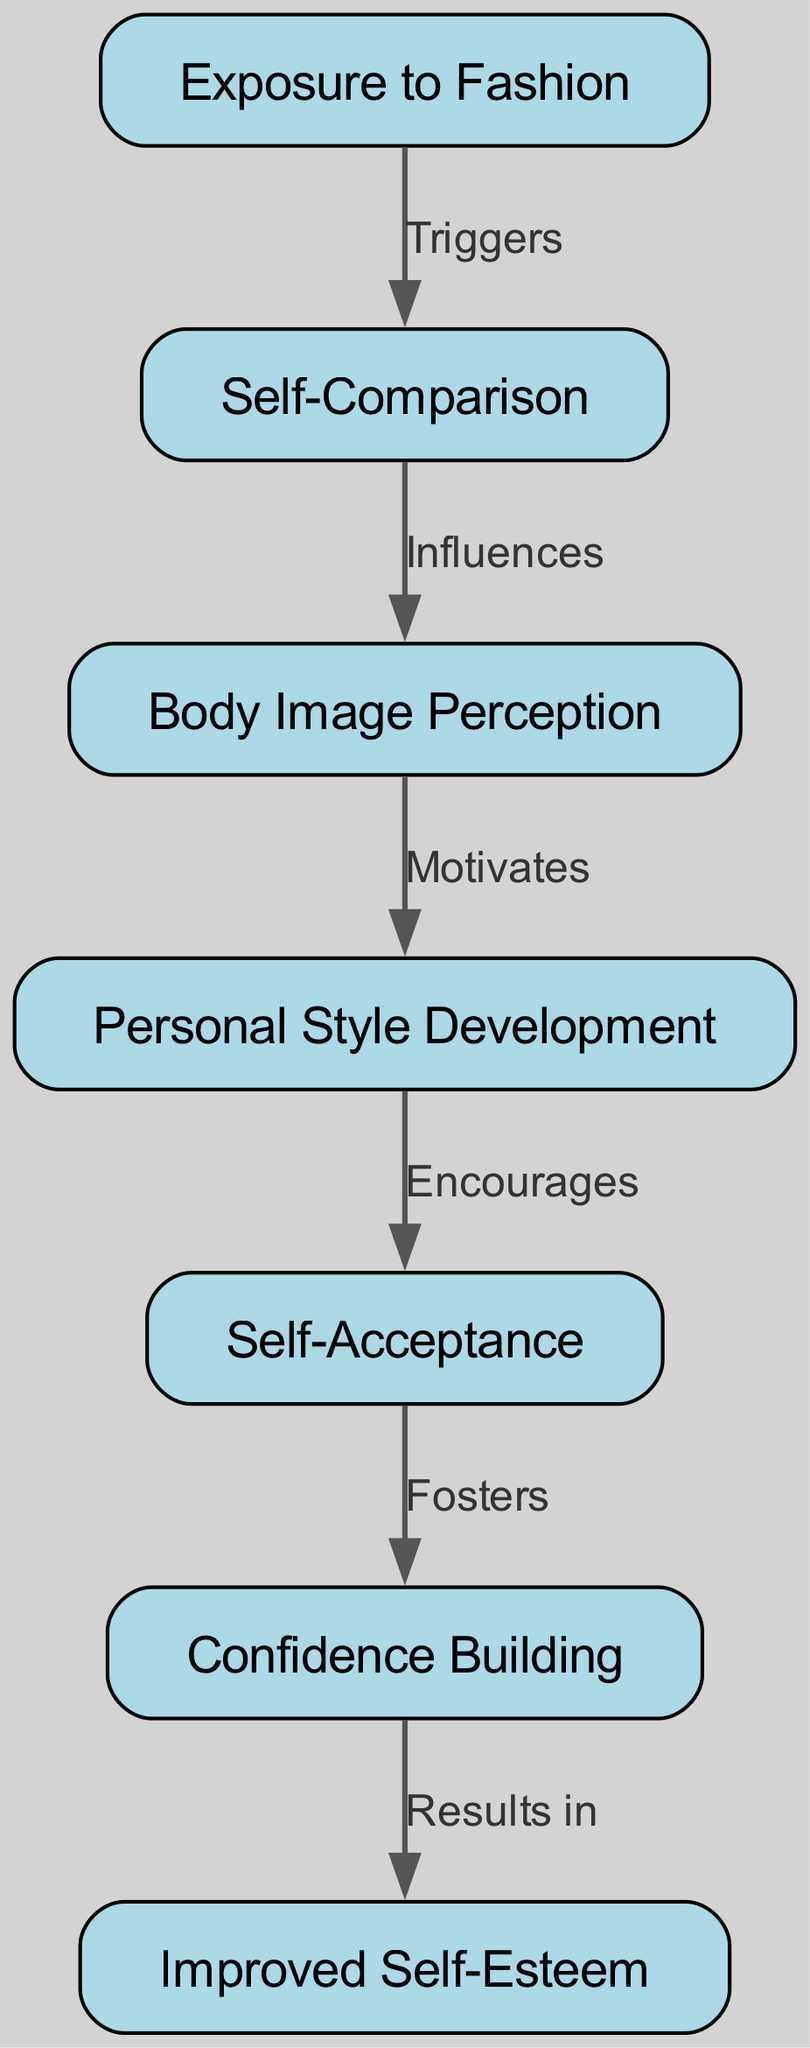What is the first node in the diagram? The first node is identified in the flowchart as the starting point of the cognitive processes illustrated. In this case, the first node is labeled "Exposure to Fashion."
Answer: Exposure to Fashion How many nodes are present in the diagram? To determine the number of nodes, we can count each individual node listed in the provided data under the "nodes" section. There are a total of 7 nodes in the diagram.
Answer: 7 What is the last node in the flowchart? The last node in the flowchart represents the final outcome of the cognitive processes described. It is labeled "Improved Self-Esteem."
Answer: Improved Self-Esteem Which node is influenced by self-comparison? In the diagram, the relationship shows that the node "Self-Comparison" directly influences the subsequent node. Upon checking the edges, the node that follows "Self-Comparison" is "Body Image Perception."
Answer: Body Image Perception What process motivates personal style development? To find which node motivates the "Personal Style Development," we look for the edge that is outgoing from "Body Image Perception." In the diagram, "Body Image Perception" motivates the "Personal Style Development."
Answer: Body Image Perception motivates What relationship connects self-acceptance and confidence building? The diagram has an edge that connects "Self-Acceptance" to "Confidence Building," which states that self-acceptance fosters confidence building. The term used to describe this relationship is "Fosters."
Answer: Fosters How does exposure to fashion lead to improved self-esteem? To understand how "Exposure to Fashion" leads to "Improved Self-Esteem," we trace through the following series of relationships: "Exposure to Fashion" triggers "Self-Comparison," which influences "Body Image Perception," that motivates "Personal Style Development," which encourages "Self-Acceptance," eventually fostering "Confidence Building" that results in "Improved Self-Esteem." The entire flow shows the progression from exposure to the final outcome.
Answer: Through sequential cognitive processes Which node encourages self-acceptance? We examine which node influences "Self-Acceptance." The previous node is "Personal Style Development," which means it encourages self-acceptance according to the diagram's edge connections.
Answer: Personal Style Development What is the connecting term between confidence building and improved self-esteem? The direct relationship between "Confidence Building" and "Improved Self-Esteem" is represented by the term "Results in," which indicates the outcome of confidence building.
Answer: Results in 